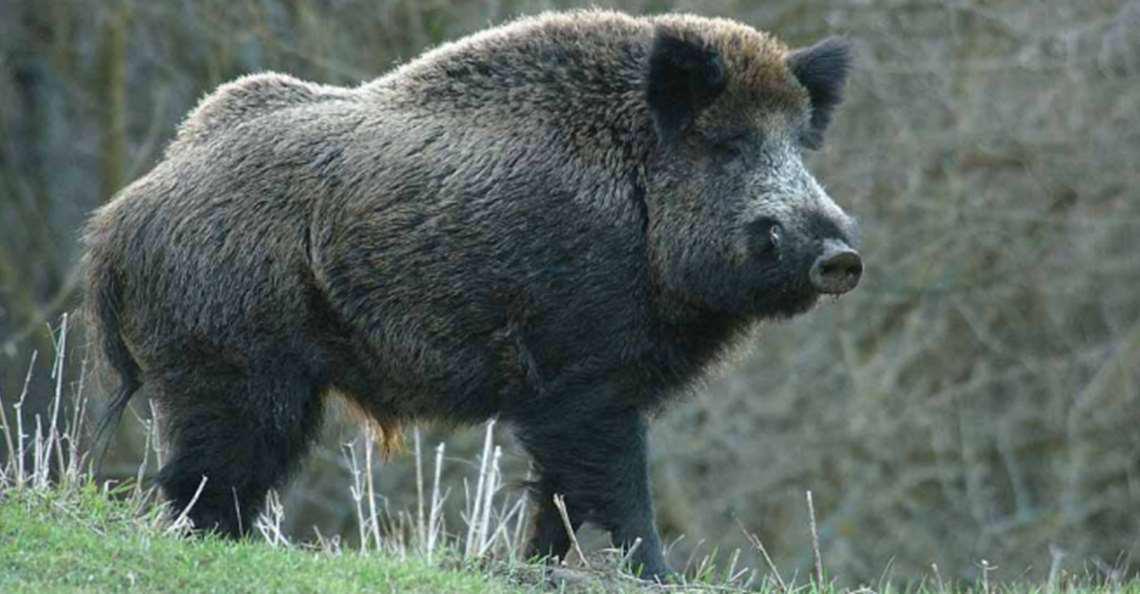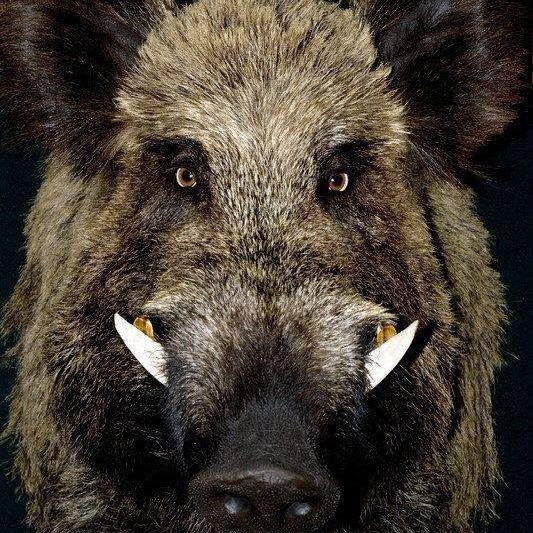The first image is the image on the left, the second image is the image on the right. Given the left and right images, does the statement "There are at least two animals in the image on the left." hold true? Answer yes or no. No. 